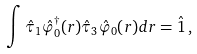<formula> <loc_0><loc_0><loc_500><loc_500>\int \hat { \tau } _ { 1 } \hat { \varphi } _ { 0 } ^ { \dagger } ( { r } ) \hat { \tau } _ { 3 } \hat { \varphi } _ { 0 } ( { r } ) d { r } = \hat { 1 } \, ,</formula> 